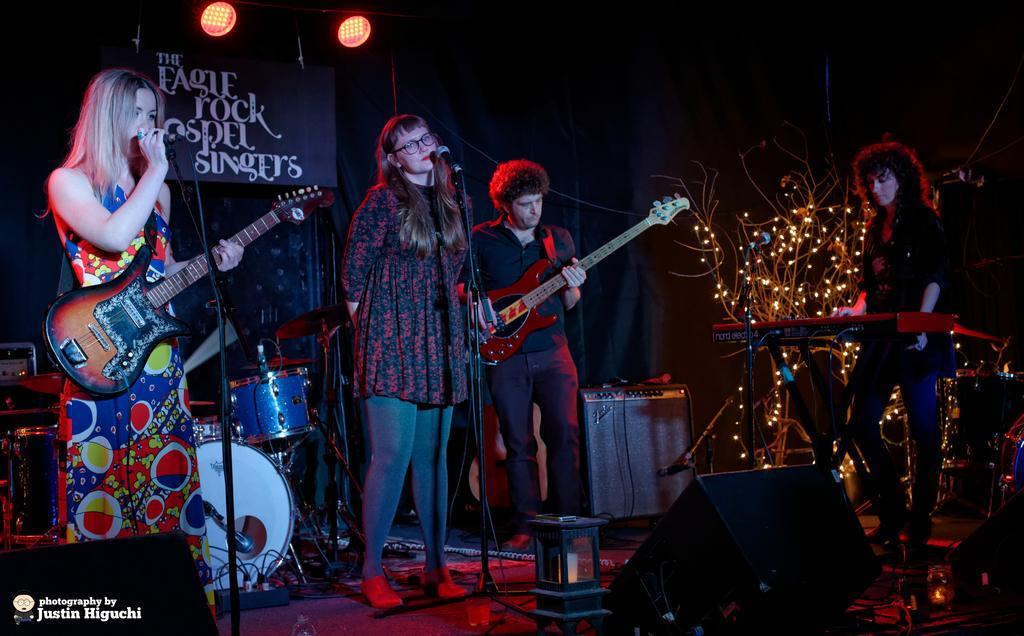Please provide a concise description of this image. A rock band is performing in an event. The band consists of three women and a man. 